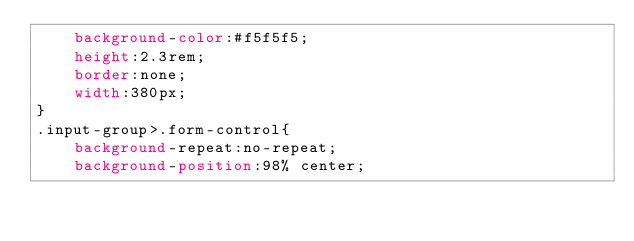<code> <loc_0><loc_0><loc_500><loc_500><_CSS_>    background-color:#f5f5f5;
    height:2.3rem;
    border:none;
    width:380px;
}
.input-group>.form-control{
    background-repeat:no-repeat;
    background-position:98% center;</code> 